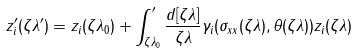Convert formula to latex. <formula><loc_0><loc_0><loc_500><loc_500>z _ { i } ^ { \prime } ( \zeta \lambda ^ { \prime } ) = z _ { i } ( \zeta \lambda _ { 0 } ) + \int _ { \zeta \lambda _ { 0 } } ^ { \prime } \frac { d [ \zeta \lambda ] } { \zeta \lambda } \gamma _ { i } ( \sigma _ { x x } ( \zeta \lambda ) , \theta ( \zeta \lambda ) ) z _ { i } ( \zeta \lambda )</formula> 